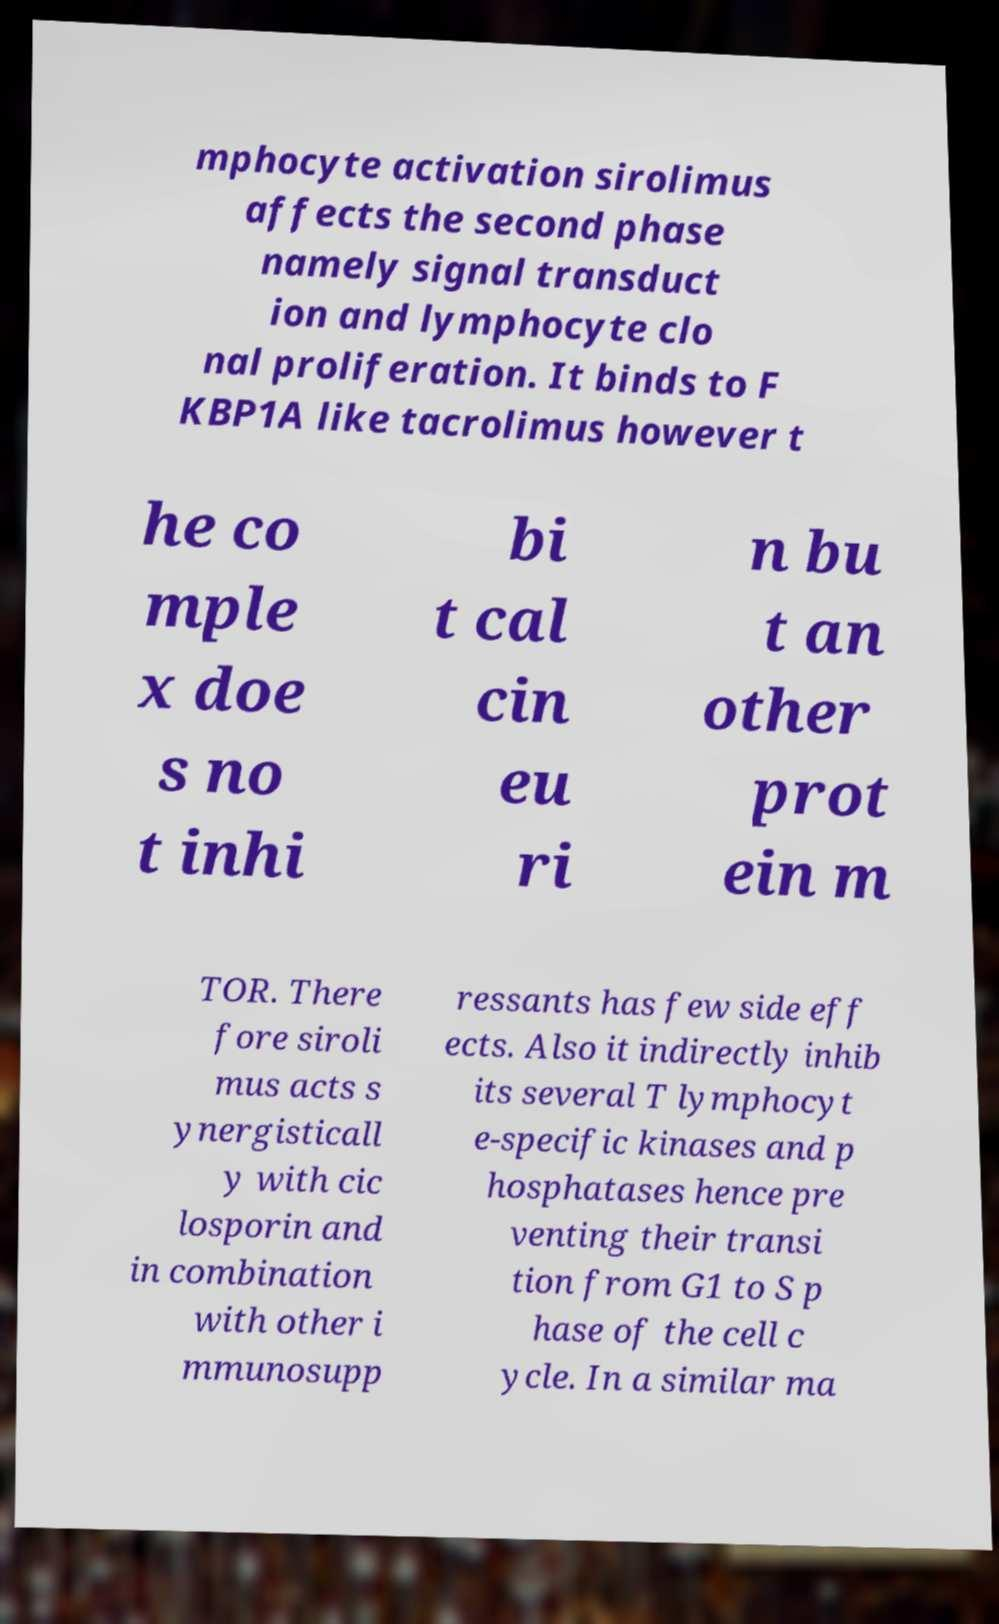Please identify and transcribe the text found in this image. mphocyte activation sirolimus affects the second phase namely signal transduct ion and lymphocyte clo nal proliferation. It binds to F KBP1A like tacrolimus however t he co mple x doe s no t inhi bi t cal cin eu ri n bu t an other prot ein m TOR. There fore siroli mus acts s ynergisticall y with cic losporin and in combination with other i mmunosupp ressants has few side eff ects. Also it indirectly inhib its several T lymphocyt e-specific kinases and p hosphatases hence pre venting their transi tion from G1 to S p hase of the cell c ycle. In a similar ma 